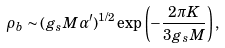<formula> <loc_0><loc_0><loc_500><loc_500>\rho _ { b } \sim ( g _ { s } M \alpha ^ { \prime } ) ^ { 1 / 2 } \exp \left ( - \frac { 2 \pi K } { 3 g _ { s } M } \right ) ,</formula> 